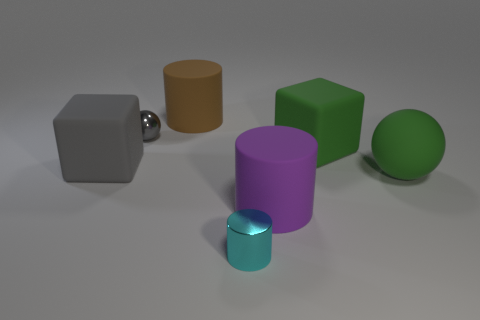Add 2 tiny green balls. How many objects exist? 9 Subtract all small shiny cylinders. How many cylinders are left? 2 Subtract all cylinders. How many objects are left? 4 Subtract all green cylinders. Subtract all yellow cubes. How many cylinders are left? 3 Add 6 tiny shiny cylinders. How many tiny shiny cylinders exist? 7 Subtract 0 gray cylinders. How many objects are left? 7 Subtract all green matte things. Subtract all large things. How many objects are left? 0 Add 4 gray metal balls. How many gray metal balls are left? 5 